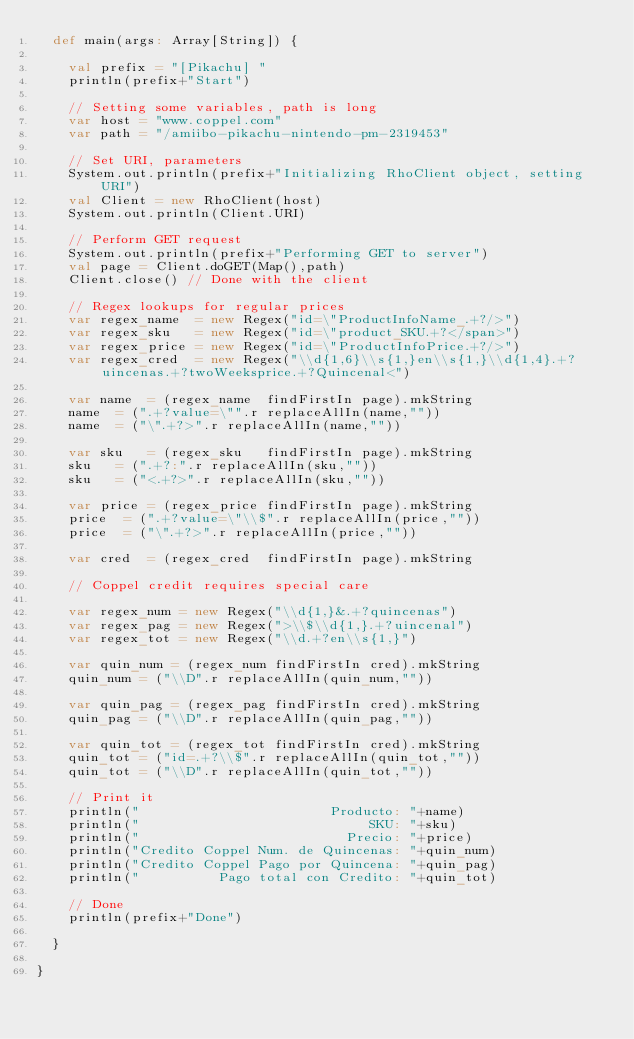Convert code to text. <code><loc_0><loc_0><loc_500><loc_500><_Scala_>  def main(args: Array[String]) {

    val prefix = "[Pikachu] "
    println(prefix+"Start")

    // Setting some variables, path is long
    var host = "www.coppel.com"
    var path = "/amiibo-pikachu-nintendo-pm-2319453"

    // Set URI, parameters
    System.out.println(prefix+"Initializing RhoClient object, setting URI")
    val Client = new RhoClient(host)
    System.out.println(Client.URI)

    // Perform GET request
    System.out.println(prefix+"Performing GET to server")  
    val page = Client.doGET(Map(),path)
    Client.close() // Done with the client

    // Regex lookups for regular prices
    var regex_name  = new Regex("id=\"ProductInfoName_.+?/>")
    var regex_sku   = new Regex("id=\"product_SKU.+?</span>")
    var regex_price = new Regex("id=\"ProductInfoPrice.+?/>")
    var regex_cred  = new Regex("\\d{1,6}\\s{1,}en\\s{1,}\\d{1,4}.+?uincenas.+?twoWeeksprice.+?Quincenal<")
  
    var name  = (regex_name  findFirstIn page).mkString
    name  = (".+?value=\"".r replaceAllIn(name,""))
    name  = ("\".+?>".r replaceAllIn(name,""))

    var sku   = (regex_sku   findFirstIn page).mkString
    sku   = (".+?:".r replaceAllIn(sku,""))
    sku   = ("<.+?>".r replaceAllIn(sku,""))

    var price = (regex_price findFirstIn page).mkString
    price  = (".+?value=\"\\$".r replaceAllIn(price,""))
    price  = ("\".+?>".r replaceAllIn(price,""))

    var cred  = (regex_cred  findFirstIn page).mkString

    // Coppel credit requires special care

    var regex_num = new Regex("\\d{1,}&.+?quincenas")
    var regex_pag = new Regex(">\\$\\d{1,}.+?uincenal")
    var regex_tot = new Regex("\\d.+?en\\s{1,}")
    
    var quin_num = (regex_num findFirstIn cred).mkString
    quin_num = ("\\D".r replaceAllIn(quin_num,""))

    var quin_pag = (regex_pag findFirstIn cred).mkString
    quin_pag = ("\\D".r replaceAllIn(quin_pag,""))

    var quin_tot = (regex_tot findFirstIn cred).mkString
    quin_tot = ("id=.+?\\$".r replaceAllIn(quin_tot,""))
    quin_tot = ("\\D".r replaceAllIn(quin_tot,""))

    // Print it
    println("                        Producto: "+name)
    println("                             SKU: "+sku)
    println("                          Precio: "+price)
    println("Credito Coppel Num. de Quincenas: "+quin_num)
    println("Credito Coppel Pago por Quincena: "+quin_pag)
    println("          Pago total con Credito: "+quin_tot)    

    // Done
    println(prefix+"Done")
  
  }

}
</code> 